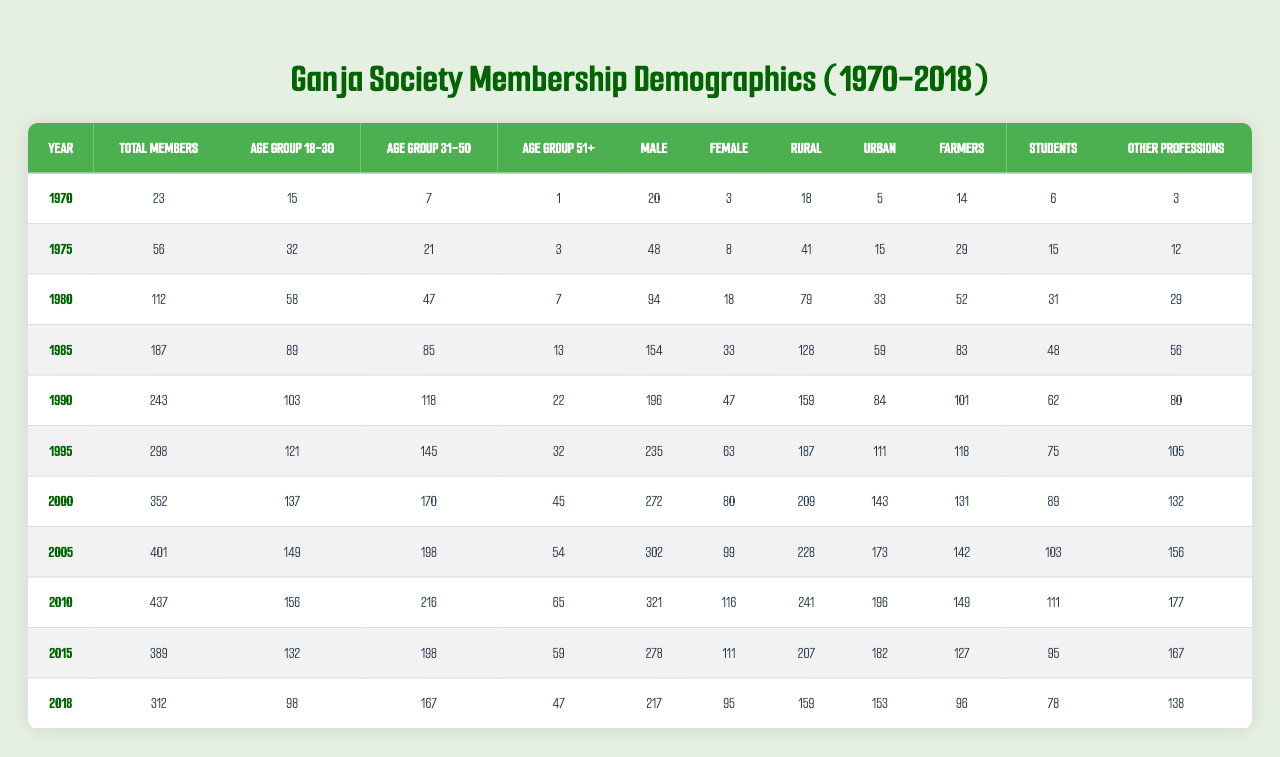What was the total number of members in the year 1980? In the row for the year 1980, I can directly find the value in the "Total Members" column, which is 112.
Answer: 112 How many female members were there in 1995? Referring to the year 1995, the number of female members is listed under the "Female" column, which shows 63.
Answer: 63 What is the highest number of members in any year? By examining the "Total Members" column across all years, I see that 401 in 2005 is the highest value compared to other years.
Answer: 401 What was the average age of members aged 31-50 from 1970 to 2018? I will sum the values in the "Age Group 31-50" column for each year: (7 + 21 + 47 + 85 + 118 + 145 + 170 + 198 + 216 + 198 + 167) = 1,224. There are 11 years, so the average is 1,224 / 11 = 111.27.
Answer: 111.27 Was the total membership higher in 2000 than in 2010? Checking the "Total Members" column, 352 in 2000 is less than 437 in 2010, making the statement false.
Answer: No How many male members were there in 1975 and how much did it increase by 1985? In 1975, the number of male members was 48, and in 1985, it was 154. The increase can be calculated as 154 - 48 = 106.
Answer: 106 What percentage of total members were students in 1990? For 1990, the total number of members is 243 and the number of students is 62. The percentage is (62 / 243) * 100 = 25.57%.
Answer: 25.57% Which age group had the least number of members in 2018? In 2018, looking at the age groups, there are 98 in the 18-30 group, 167 in the 31-50 group, and 47 in the 51+ group. The least is the 51+ group with 47 members.
Answer: 51+ group What was the total number of female members from 1970 to 2018? I will sum the female member counts across all years: (3 + 8 + 18 + 33 + 47 + 63 + 80 + 99 + 116 + 111 + 95) =  675.
Answer: 675 Did the number of rural members decrease from 2005 to 2018? In 2005, the number of rural members was 228 and in 2018 it was 159. Since 228 is greater than 159, the number decreased.
Answer: Yes 